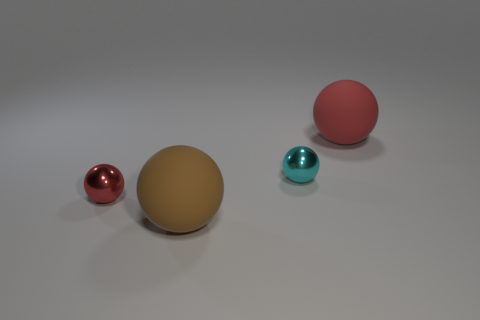How many objects are big balls to the left of the cyan shiny ball or matte balls in front of the small red object?
Your response must be concise. 1. How many purple objects are either big cubes or big spheres?
Provide a short and direct response. 0. The thing that is in front of the small cyan sphere and behind the brown thing is made of what material?
Your answer should be compact. Metal. Do the tiny cyan object and the brown ball have the same material?
Give a very brief answer. No. How many cyan objects have the same size as the red shiny thing?
Your answer should be very brief. 1. Is the number of small balls that are behind the small red ball the same as the number of big balls?
Your response must be concise. No. What number of things are behind the big brown matte thing and on the left side of the red rubber ball?
Your answer should be very brief. 2. There is a small object in front of the cyan metallic object; is its shape the same as the small cyan metal thing?
Offer a terse response. Yes. What material is the object that is the same size as the red shiny ball?
Provide a succinct answer. Metal. Are there the same number of tiny red things to the right of the red rubber object and metallic spheres that are on the right side of the small cyan ball?
Offer a very short reply. Yes. 